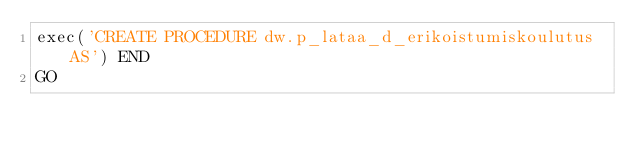<code> <loc_0><loc_0><loc_500><loc_500><_SQL_>exec('CREATE PROCEDURE dw.p_lataa_d_erikoistumiskoulutus AS') END
GO
</code> 